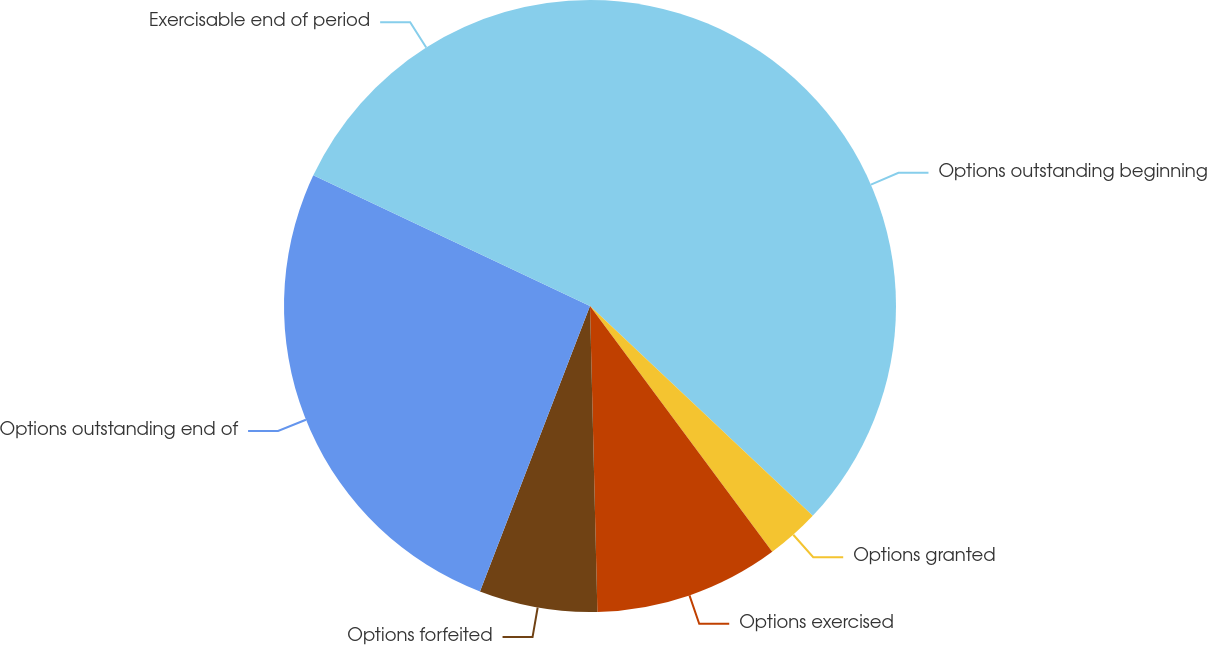Convert chart. <chart><loc_0><loc_0><loc_500><loc_500><pie_chart><fcel>Options outstanding beginning<fcel>Options granted<fcel>Options exercised<fcel>Options forfeited<fcel>Options outstanding end of<fcel>Exercisable end of period<nl><fcel>37.03%<fcel>2.82%<fcel>9.77%<fcel>6.24%<fcel>26.17%<fcel>17.98%<nl></chart> 